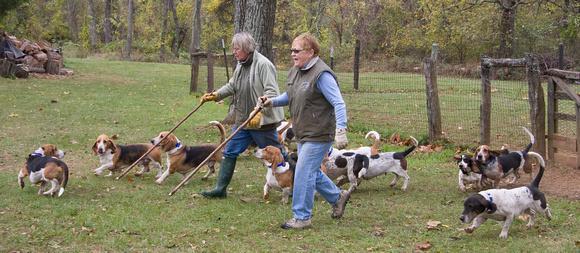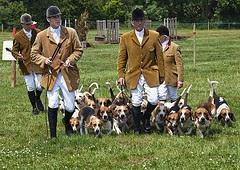The first image is the image on the left, the second image is the image on the right. Assess this claim about the two images: "Each image shows exactly two species of mammal.". Correct or not? Answer yes or no. Yes. 